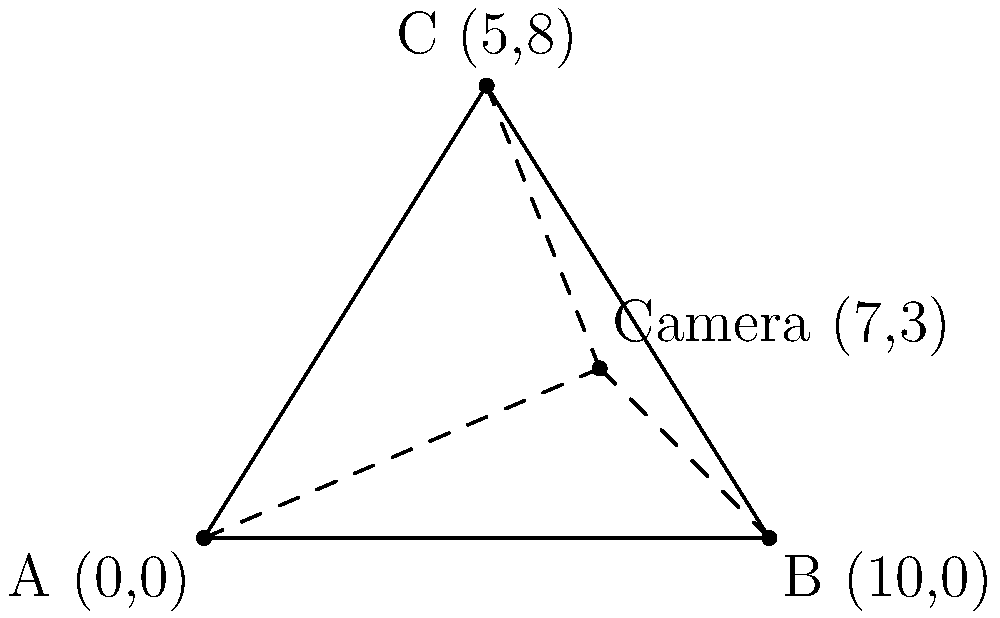A surveillance camera is set up to monitor a triangular area defined by three known landmarks: A (0,0), B (10,0), and C (5,8). The camera's field of view angles are measured from each landmark: $\angle BAC = 53.1°$, $\angle ABC = 36.9°$, and $\angle ACB = 90.0°$. Using these angles and the known coordinates, determine the position of the surveillance camera. Round your answer to the nearest whole number. To find the position of the surveillance camera, we'll use the concept of triangle centers, specifically the incenter. The incenter is the point where the angle bisectors of a triangle intersect.

1) First, we need to calculate the side lengths of the triangle:
   AB = $\sqrt{(10-0)^2 + (0-0)^2} = 10$
   BC = $\sqrt{(5-10)^2 + (8-0)^2} = \sqrt{25 + 64} = \sqrt{89} \approx 9.43$
   AC = $\sqrt{(5-0)^2 + (8-0)^2} = \sqrt{25 + 64} = \sqrt{89} \approx 9.43$

2) The incenter divides each angle bisector in the ratio of the lengths of the sides containing the angle. Let's call the incenter I(x,y). We can use the following formulas:

   $x = \frac{a \cdot x_A + b \cdot x_B + c \cdot x_C}{a + b + c}$
   $y = \frac{a \cdot y_A + b \cdot y_B + c \cdot y_C}{a + b + c}$

   Where a, b, and c are the lengths of the sides opposite to vertices A, B, and C respectively.

3) Substituting the values:
   $x = \frac{9.43 \cdot 0 + 9.43 \cdot 10 + 10 \cdot 5}{9.43 + 9.43 + 10} \approx 6.97$
   $y = \frac{9.43 \cdot 0 + 9.43 \cdot 0 + 10 \cdot 8}{9.43 + 9.43 + 10} \approx 2.76$

4) Rounding to the nearest whole number:
   x ≈ 7
   y ≈ 3

Therefore, the position of the surveillance camera is approximately (7,3).
Answer: (7,3) 